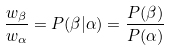<formula> <loc_0><loc_0><loc_500><loc_500>\frac { w _ { \beta } } { w _ { \alpha } } = P ( \beta | \alpha ) = \frac { P ( \beta ) } { P ( \alpha ) }</formula> 